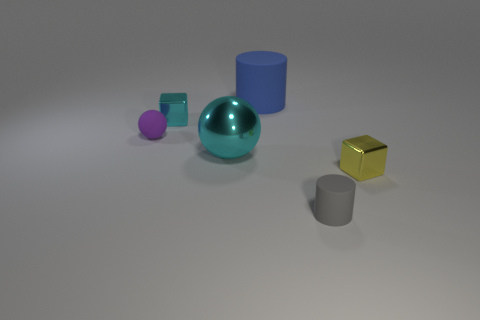Add 4 shiny balls. How many objects exist? 10 Subtract all cubes. How many objects are left? 4 Add 5 brown rubber cylinders. How many brown rubber cylinders exist? 5 Subtract 1 yellow blocks. How many objects are left? 5 Subtract all cyan rubber spheres. Subtract all gray objects. How many objects are left? 5 Add 4 tiny yellow shiny cubes. How many tiny yellow shiny cubes are left? 5 